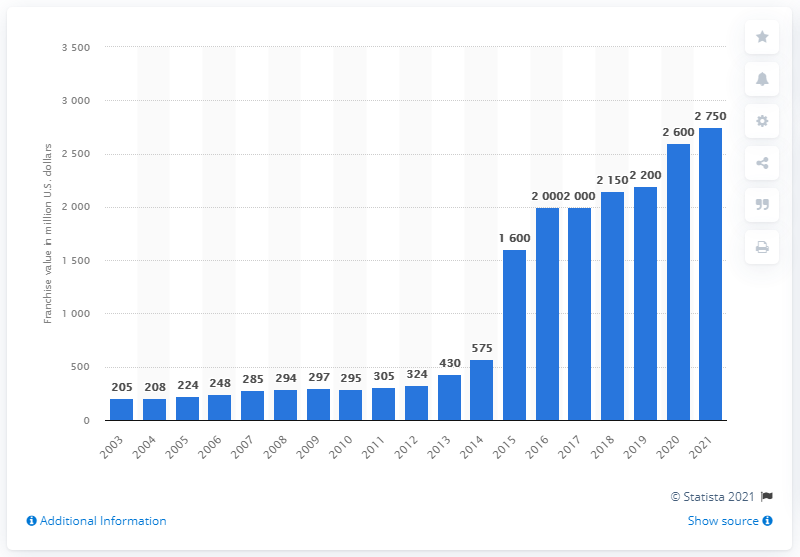Draw attention to some important aspects in this diagram. In 2021, the estimated value of the Los Angeles Clippers was approximately 2,750. 